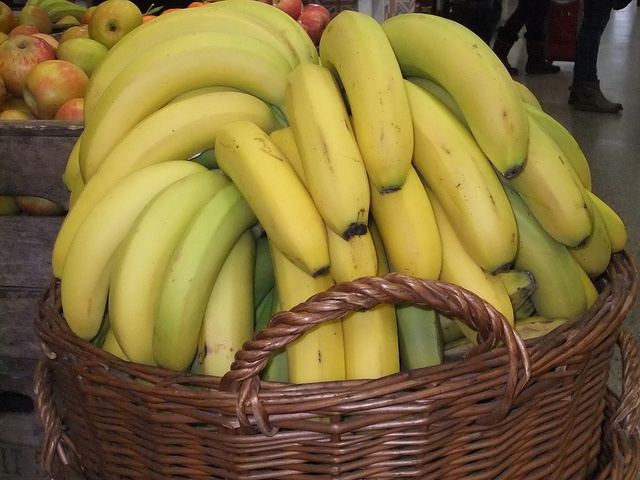Describe the objects in this image and their specific colors. I can see banana in black, khaki, and olive tones, apple in black, olive, and maroon tones, people in black, gray, and darkgray tones, apple in black, olive, maroon, and tan tones, and people in black and gray tones in this image. 